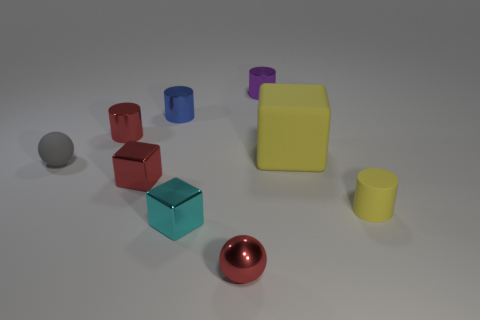What color is the other object that is the same shape as the gray rubber thing?
Make the answer very short. Red. The tiny gray object has what shape?
Keep it short and to the point. Sphere. How many things are either small cyan metal blocks or tiny red rubber balls?
Offer a very short reply. 1. Do the shiny cube that is behind the small matte cylinder and the small rubber thing that is on the left side of the red cylinder have the same color?
Provide a succinct answer. No. How many other objects are the same shape as the cyan metal object?
Provide a succinct answer. 2. Are there any green things?
Your answer should be compact. No. What number of objects are either blue things or cylinders to the right of the red metal sphere?
Ensure brevity in your answer.  3. There is a red metal thing that is on the right side of the red metallic cube; is its size the same as the yellow block?
Give a very brief answer. No. What number of other objects are there of the same size as the yellow cylinder?
Your answer should be very brief. 7. What color is the big rubber thing?
Give a very brief answer. Yellow. 